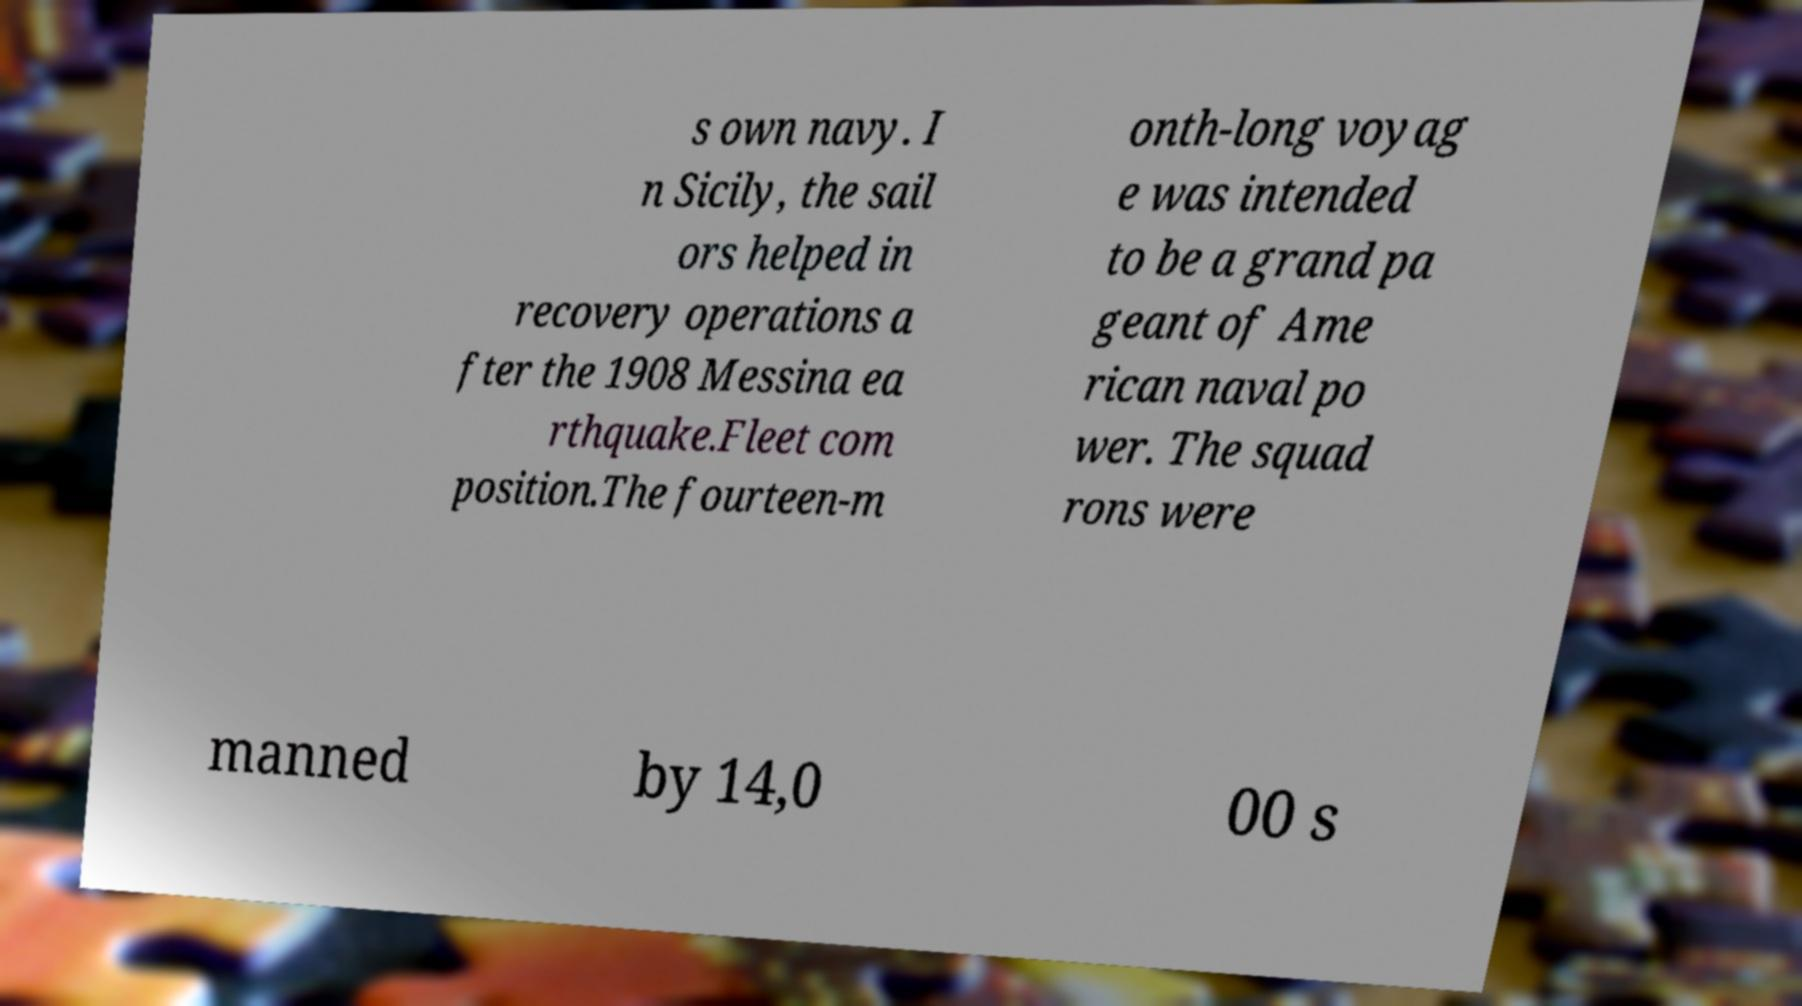Please identify and transcribe the text found in this image. s own navy. I n Sicily, the sail ors helped in recovery operations a fter the 1908 Messina ea rthquake.Fleet com position.The fourteen-m onth-long voyag e was intended to be a grand pa geant of Ame rican naval po wer. The squad rons were manned by 14,0 00 s 